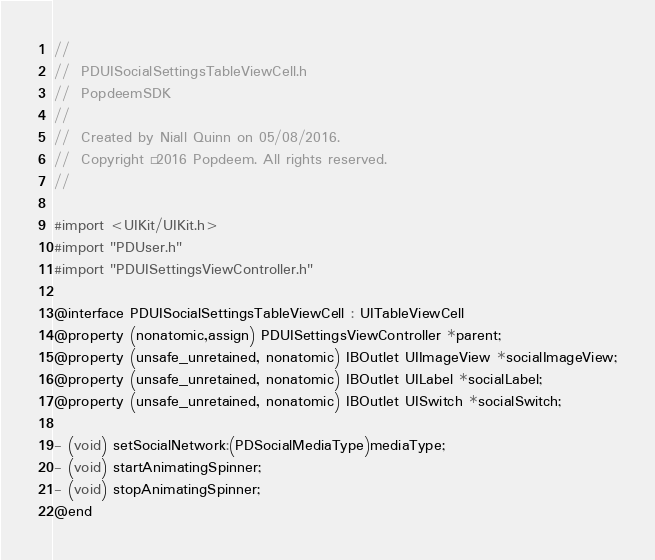<code> <loc_0><loc_0><loc_500><loc_500><_C_>//
//  PDUISocialSettingsTableViewCell.h
//  PopdeemSDK
//
//  Created by Niall Quinn on 05/08/2016.
//  Copyright © 2016 Popdeem. All rights reserved.
//

#import <UIKit/UIKit.h>
#import "PDUser.h"
#import "PDUISettingsViewController.h"

@interface PDUISocialSettingsTableViewCell : UITableViewCell
@property (nonatomic,assign) PDUISettingsViewController *parent;
@property (unsafe_unretained, nonatomic) IBOutlet UIImageView *socialImageView;
@property (unsafe_unretained, nonatomic) IBOutlet UILabel *socialLabel;
@property (unsafe_unretained, nonatomic) IBOutlet UISwitch *socialSwitch;

- (void) setSocialNetwork:(PDSocialMediaType)mediaType;
- (void) startAnimatingSpinner;
- (void) stopAnimatingSpinner;
@end
</code> 